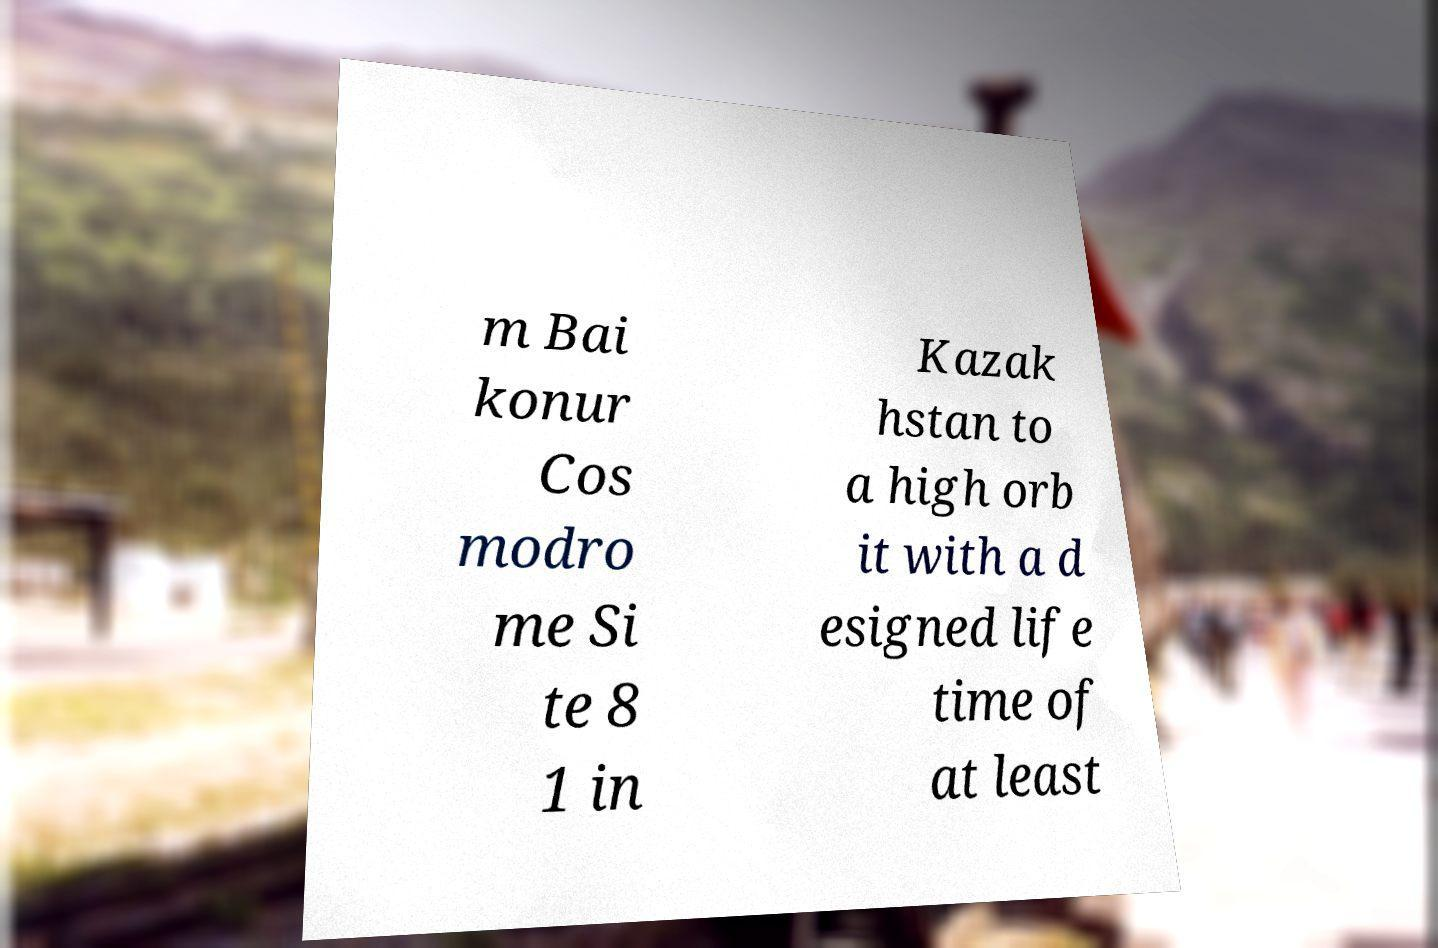Can you accurately transcribe the text from the provided image for me? m Bai konur Cos modro me Si te 8 1 in Kazak hstan to a high orb it with a d esigned life time of at least 